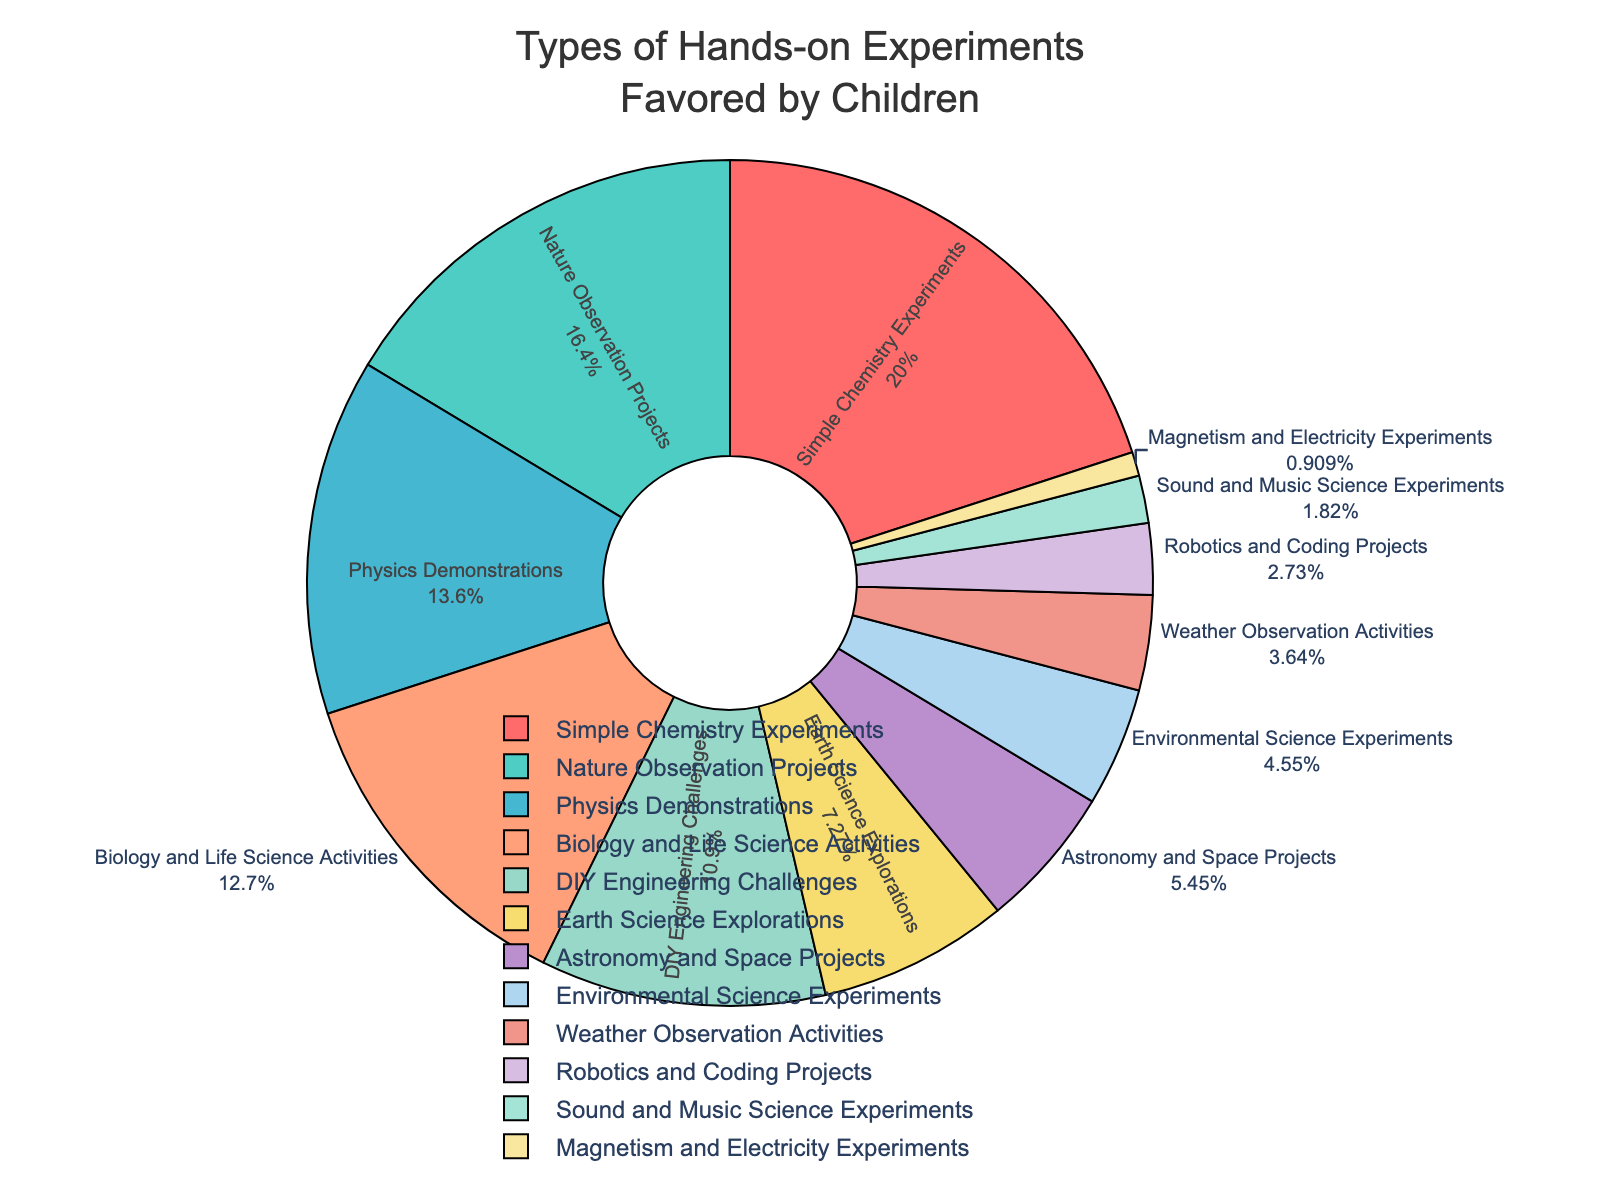What's the most favored type of experiment by children? By looking at the segment that occupies the largest area in the pie chart and noting its label, we can determine the most favored experiment. It is "Simple Chemistry Experiments" with 22%.
Answer: Simple Chemistry Experiments What's the least favored type of experiment by children? By locating the smallest segment in the pie chart and noting its label, it is identified as "Magnetism and Electricity Experiments" with 1%.
Answer: Magnetism and Electricity Experiments How many experiment types are favored by at least 10% of children? To arrive at the answer, count the segments that have a percentage value of 10% or greater. The experiment types that meet this criterion are: Simple Chemistry Experiments (22%), Nature Observation Projects (18%), Physics Demonstrations (15%), Biology and Life Science Activities (14%), and DIY Engineering Challenges (12%). This gives us five experiment types.
Answer: 5 Are there more children who favor "Astronomy and Space Projects" or "Earth Science Explorations"? Compare the percentages for "Astronomy and Space Projects" (6%) and "Earth Science Explorations" (8%). Since 8% is greater than 6%, more children favor Earth Science Explorations.
Answer: Earth Science Explorations What is the combined percentage of children who favor "Robotics and Coding Projects" and "Sound and Music Science Experiments"? Add the percentages for "Robotics and Coding Projects" (3%) and "Sound and Music Science Experiments" (2%). 3% + 2% equals 5%.
Answer: 5% Which experiment type is represented by the red color? By visually identifying the red segment in the pie chart and its associated label, it is "Simple Chemistry Experiments"
Answer: Simple Chemistry Experiments Which experiment types have a percentage difference of 1% between them? Identify pairs of experiment types with a 1% difference by examining the percentage values closely. The pairs with this difference are: "Environmental Science Experiments" (5%) and "Weather Observation Activities" (4%), "Sound and Music Science Experiments" (2%) and "Magnetism and Electricity Experiments" (1%).
Answer: Environmental Science Experiments and Weather Observation Activities, Sound and Music Science Experiments and Magnetism and Electricity Experiments What is the sum percentage of children favoring "Nature Observation Projects" and "Physics Demonstrations"? Sum the percentages for "Nature Observation Projects" (18%) and "Physics Demonstrations" (15%). 18% + 15% equals 33%.
Answer: 33% Is "DIY Engineering Challenges" favored more or less than "Biology and Life Science Activities"? Compare the percentages for "DIY Engineering Challenges" (12%) and "Biology and Life Science Activities" (14%). Since 12% is less than 14%, "DIY Engineering Challenges" is favored less.
Answer: Less 